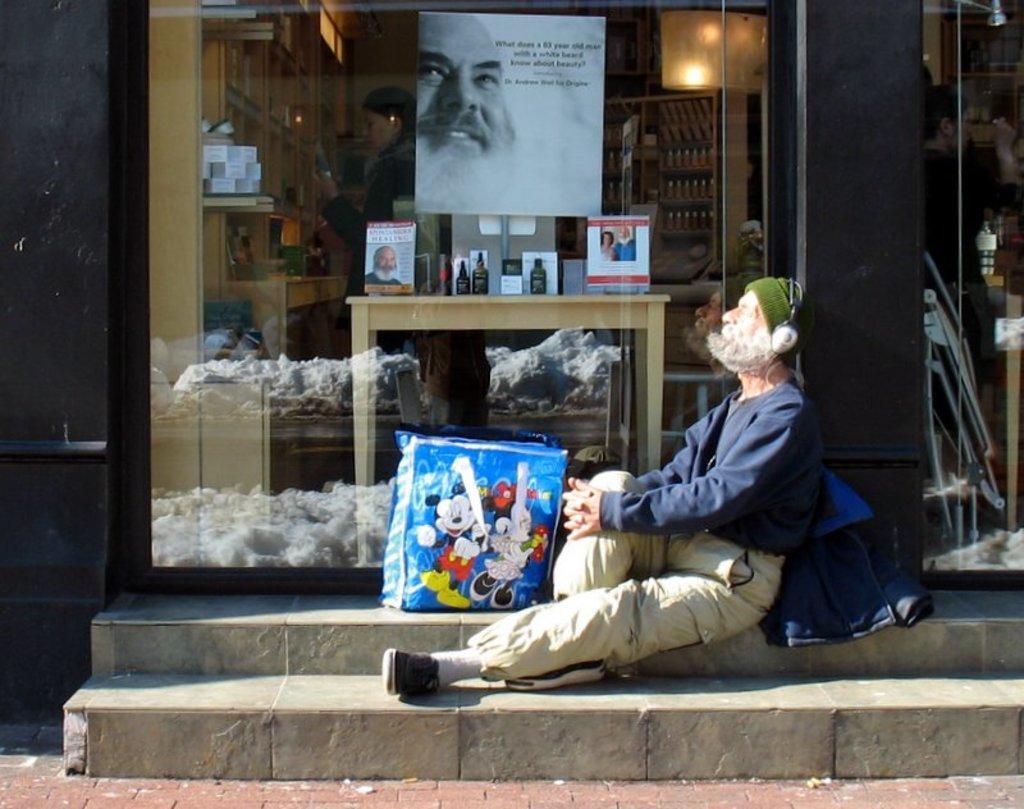How would you summarize this image in a sentence or two? In the image there is an old man in navy blue sweatshirt and jeans sitting on steps in front of a store with books and bottles inside it on a table and on racks. 